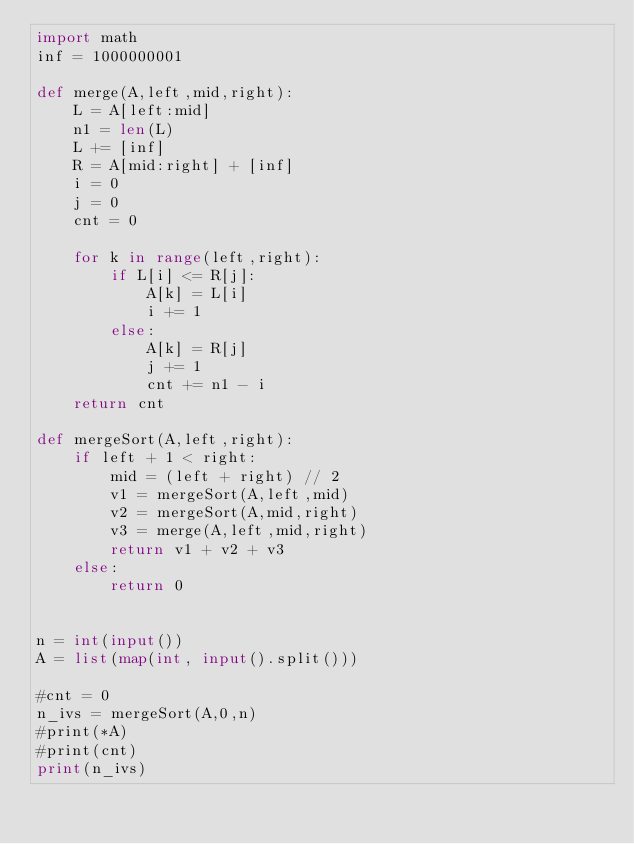Convert code to text. <code><loc_0><loc_0><loc_500><loc_500><_Python_>import math
inf = 1000000001

def merge(A,left,mid,right):
	L = A[left:mid] 
	n1 = len(L)
	L += [inf]
	R = A[mid:right] + [inf]
	i = 0
	j = 0
	cnt = 0
	
	for k in range(left,right):
		if L[i] <= R[j]:
			A[k] = L[i]
			i += 1
		else:
			A[k] = R[j]
			j += 1
			cnt += n1 - i
	return cnt

def mergeSort(A,left,right):
	if left + 1 < right:
		mid = (left + right) // 2
		v1 = mergeSort(A,left,mid)
		v2 = mergeSort(A,mid,right)
		v3 = merge(A,left,mid,right)
		return v1 + v2 + v3
	else:
		return 0
	

n = int(input())
A = list(map(int, input().split()))

#cnt = 0
n_ivs = mergeSort(A,0,n)
#print(*A)
#print(cnt)
print(n_ivs)
</code> 